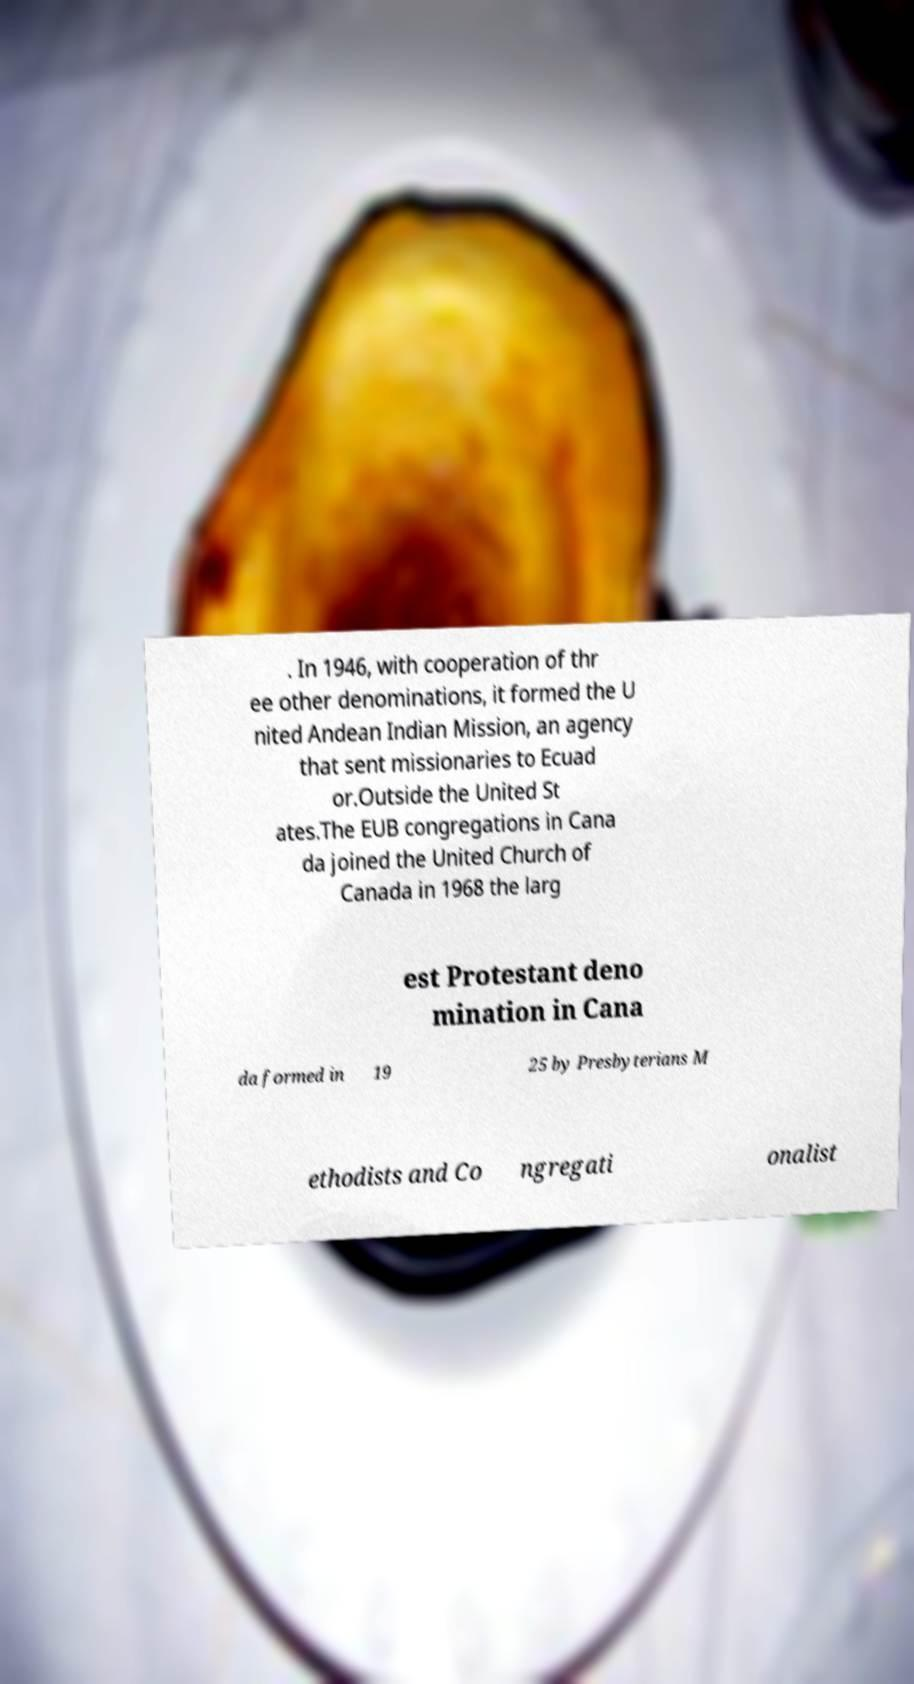There's text embedded in this image that I need extracted. Can you transcribe it verbatim? . In 1946, with cooperation of thr ee other denominations, it formed the U nited Andean Indian Mission, an agency that sent missionaries to Ecuad or.Outside the United St ates.The EUB congregations in Cana da joined the United Church of Canada in 1968 the larg est Protestant deno mination in Cana da formed in 19 25 by Presbyterians M ethodists and Co ngregati onalist 